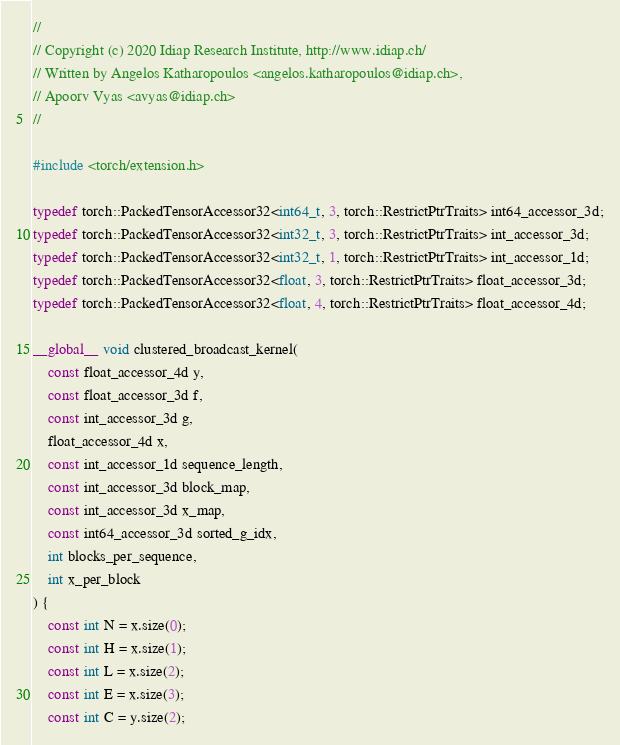Convert code to text. <code><loc_0><loc_0><loc_500><loc_500><_Cuda_>//
// Copyright (c) 2020 Idiap Research Institute, http://www.idiap.ch/
// Written by Angelos Katharopoulos <angelos.katharopoulos@idiap.ch>,
// Apoorv Vyas <avyas@idiap.ch>
//

#include <torch/extension.h>

typedef torch::PackedTensorAccessor32<int64_t, 3, torch::RestrictPtrTraits> int64_accessor_3d;
typedef torch::PackedTensorAccessor32<int32_t, 3, torch::RestrictPtrTraits> int_accessor_3d;
typedef torch::PackedTensorAccessor32<int32_t, 1, torch::RestrictPtrTraits> int_accessor_1d;
typedef torch::PackedTensorAccessor32<float, 3, torch::RestrictPtrTraits> float_accessor_3d;
typedef torch::PackedTensorAccessor32<float, 4, torch::RestrictPtrTraits> float_accessor_4d;

__global__ void clustered_broadcast_kernel(
    const float_accessor_4d y,
    const float_accessor_3d f,
    const int_accessor_3d g,
    float_accessor_4d x,
    const int_accessor_1d sequence_length,
    const int_accessor_3d block_map,
    const int_accessor_3d x_map,
    const int64_accessor_3d sorted_g_idx,
    int blocks_per_sequence,
    int x_per_block
) {
    const int N = x.size(0);
    const int H = x.size(1);
    const int L = x.size(2);
    const int E = x.size(3);
    const int C = y.size(2);
</code> 